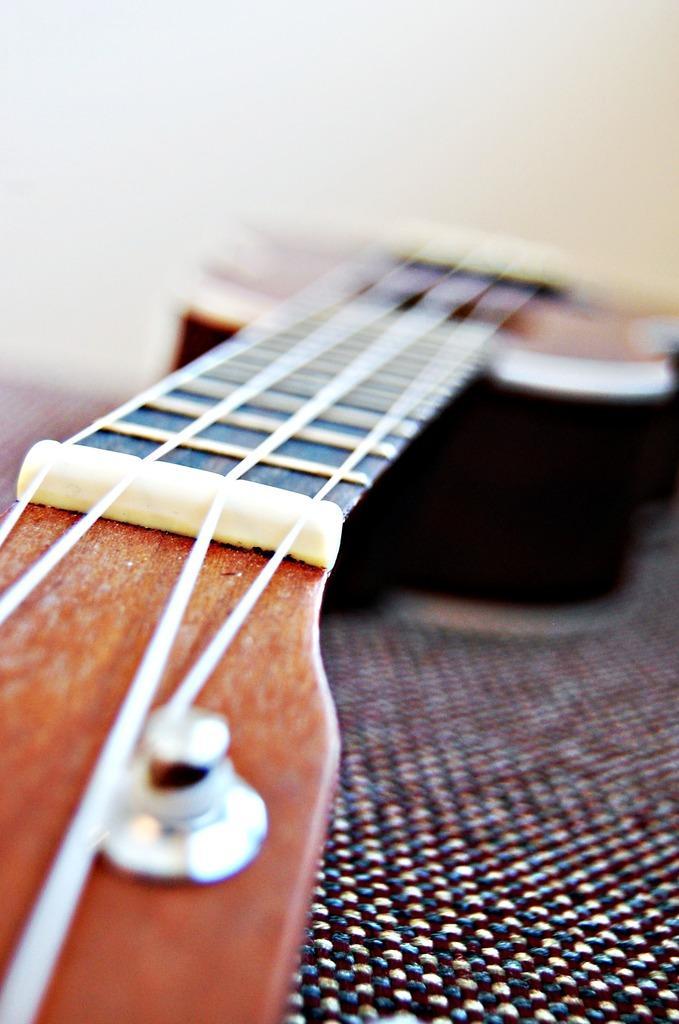Can you describe this image briefly? In the image we can see there is a guitar. Over here which is blur and on the other side strings are visible clearly. 